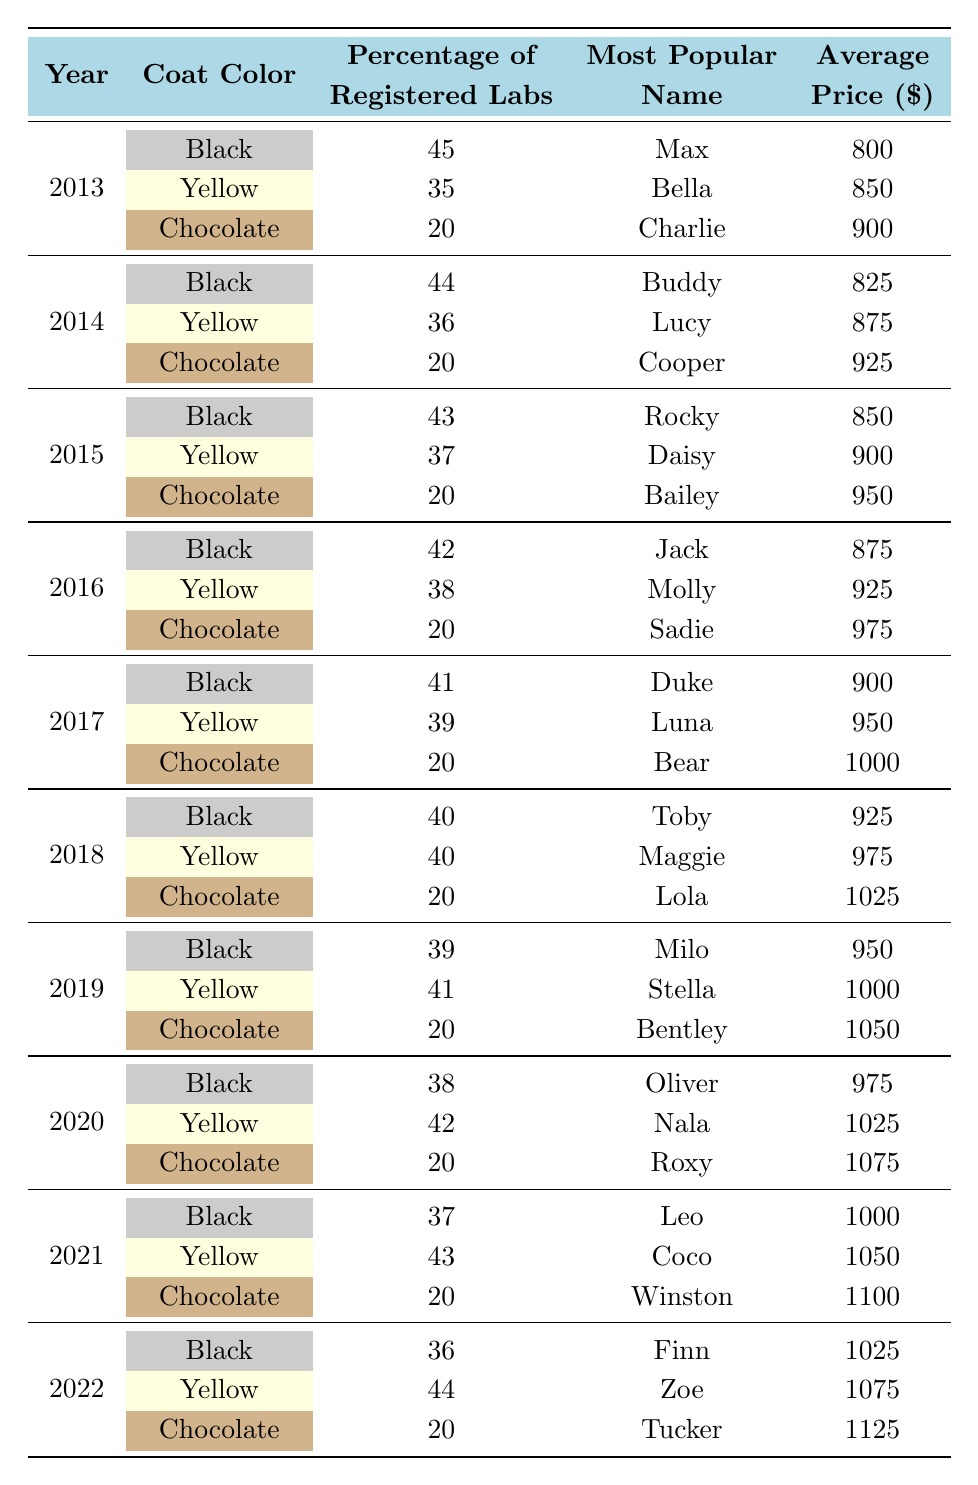What was the most popular coat color in 2013? In the 2013 data row, the coat color with the highest percentage of registered Labs is Black, with 45%.
Answer: Black Which year had the highest average price for a Chocolate Labrador? The average price of a Chocolate Labrador has been consistently $20, but in the year 2022, it was listed at $1125, which is the highest average price for a Chocolate Labrador over the years.
Answer: 2022 What is the total percentage of registered Yellow Labradors across all years? To find this, we sum the percentages of Yellow Labradors from each year: 35 (2013) + 36 (2014) + 37 (2015) + 38 (2016) + 39 (2017) + 40 (2018) + 41 (2019) + 42 (2020) + 43 (2021) + 44 (2022) =  415%.
Answer: 415% Did the percentage of registered Black Labradors decrease every year from 2013 to 2022? A quick comparison shows the percentages for Black Labradors: 45% (2013), 44% (2014), 43% (2015), 42% (2016), 41% (2017), 40% (2018), 39% (2019), 38% (2020), 37% (2021), 36% (2022). The percentage decreased each year, confirming the statement is true.
Answer: Yes Which coat color had the most popular name "Coco" and in which year? The name "Coco" was the most popular for Yellow Labradors in 2021, with a registered percentage of 43%.
Answer: Yellow, 2021 What was the average price increase for Yellow Labradors from 2013 to 2022? The average price for Yellow Labradors in 2013 was $850 and in 2022 it was $1075, so the increase is $1075 - $850 = $225.
Answer: $225 Which year had the same percentage of registered Chocolate Labradors as the year before? The percentage of registered Chocolate Labradors has consistently been 20% from 2013 to 2022, indicating that all years show the same percentage compared to the previous one.
Answer: All years What was the trend for the most popular names for Black Labradors from 2013 to 2022? The most popular names for Black Labradors were Max (2013), Buddy (2014), Rocky (2015), Jack (2016), Duke (2017), Toby (2018), Milo (2019), Oliver (2020), Leo (2021), and Finn (2022). Each year has a different name, indicating no repetition of names over the years.
Answer: No repetition Which coat color reached the percentage of 44 in 2022 and what is the average price for that color? The Yellow coat color reached a percentage of 44 in 2022, and the average price listed is $1075.
Answer: Yellow, $1075 How many more Black Labradors were registered compared to the lowest Chocolate Labrador percentage over the years? The highest percentage of Black Labradors was 45% (2013) and the lowest for Chocolate Labradors was consistently 20%. The difference is 45% - 20% = 25%.
Answer: 25% 